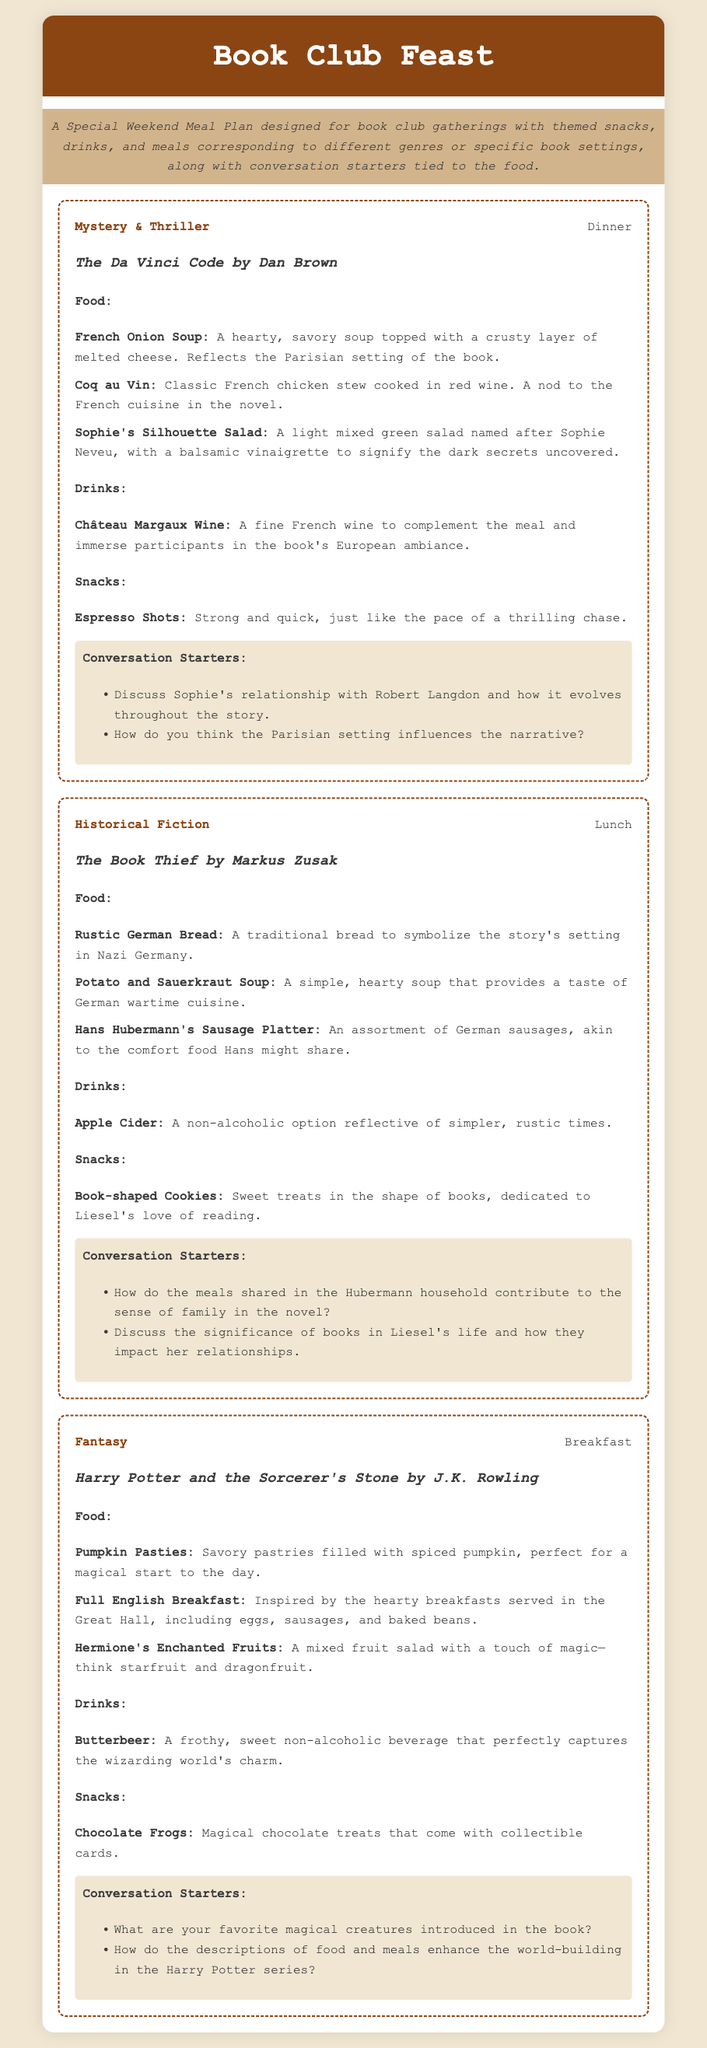What is the title of the first meal plan? The title of the first meal plan is found in the section header, which is "Mystery & Thriller" for the meal related to "The Da Vinci Code."
Answer: The Da Vinci Code What type of drink is paired with "The Book Thief"? The drink mentioned for "The Book Thief" is listed under the drinks section as a non-alcoholic option, which is "Apple Cider."
Answer: Apple Cider What genre does the meal featuring "Harry Potter and the Sorcerer's Stone" represent? The genre for the meal featuring "Harry Potter and the Sorcerer's Stone" is found in the genre header of the meal section.
Answer: Fantasy How many conversation starters are provided for the "Mystery & Thriller" meal? The number of conversation starters can be determined by counting the list items under the "Conversation Starters" heading in the "Mystery & Thriller" meal section, which shows two items.
Answer: 2 Which dish represents the character Sophie Neveu in the "Mystery & Thriller" meal? The dish representing Sophie Neveu is highlighted in the food list section, specifically named "Sophie's Silhouette Salad."
Answer: Sophie's Silhouette Salad What is a key snack listed for "Harry Potter and the Sorcerer's Stone"? The key snack is found in the snacks section under the corresponding meal and is listed as "Chocolate Frogs."
Answer: Chocolate Frogs Name one food item in the "Historical Fiction" meal plan. The food items can be retrieved by checking the food list under the "Historical Fiction" meal, where "Rustic German Bread" is one of the items.
Answer: Rustic German Bread What type of soup is served in the "Historical Fiction" meal? The soup is detailed in the food section where it describes "Potato and Sauerkraut Soup" as part of the meal.
Answer: Potato and Sauerkraut Soup What is the main theme of the gathering described in the document? The main theme is indicated in the introductory description of the document, focusing on a special meal plan for book club gatherings.
Answer: Book club gatherings 